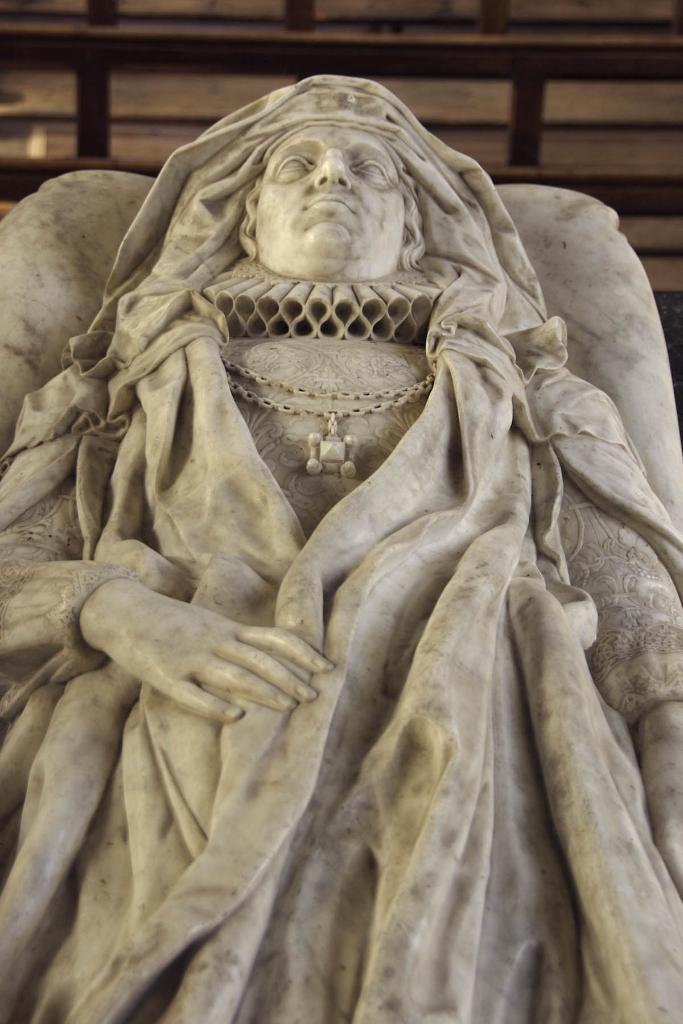Could you give a brief overview of what you see in this image? This is the sculpture of a person, which is carved with the stone. In the background, that looks like a wooden fence. 